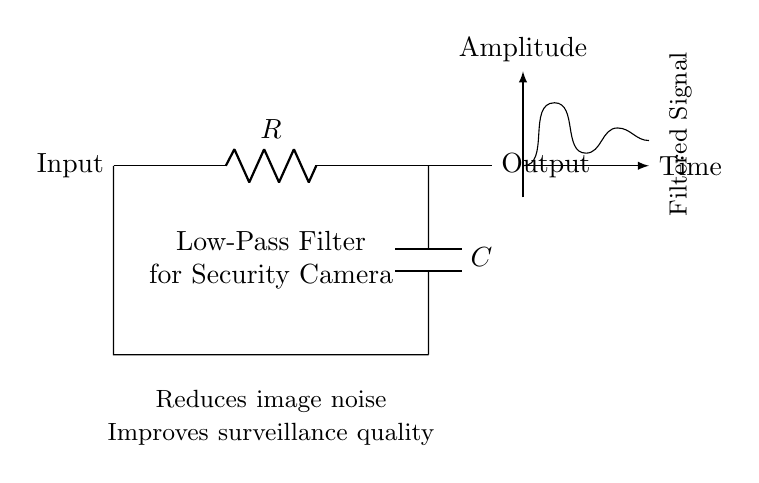What components are present in this circuit? The circuit consists of a resistor and a capacitor, labeled as R and C respectively. They are connected in a way that allows the circuit to function as a low-pass filter.
Answer: Resistor and Capacitor What is the function of this circuit? This circuit is designed to reduce image noise and improve surveillance quality in security camera systems. The low-pass filter allows low-frequency signals to pass while attenuating high-frequency noise.
Answer: Low-pass filter What is the output of this circuit? The output is filtered signals, as indicated in the circuit diagram. It shows the effectiveness of the low-pass filter in delivering a cleaner surveillance signal.
Answer: Filtered Signal Which component determines the cutoff frequency in this filter circuit? The cutoff frequency is determined by both the resistor and the capacitor values. The formula for cutoff frequency involves both components: f_c = 1 / (2πRC).
Answer: Resistor and Capacitor How does this circuit reduce image noise? The circuit reduces image noise by attenuating high-frequency signals that are often associated with noise in surveillance footage. By allowing only low-frequency signals to pass, it results in a clearer image.
Answer: Attenuates high-frequency signals What type of filter is represented in this circuit diagram? This circuit diagram represents a low-pass filter, which is specifically designed to allow low-frequency signals to pass through while blocking higher frequencies.
Answer: Low-pass filter 